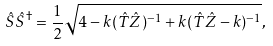Convert formula to latex. <formula><loc_0><loc_0><loc_500><loc_500>\hat { S } \hat { S } ^ { \dag } = \frac { 1 } { 2 } \sqrt { 4 - k ( \hat { T } \hat { Z } ) ^ { - 1 } + k ( \hat { T } \hat { Z } - k ) ^ { - 1 } } ,</formula> 